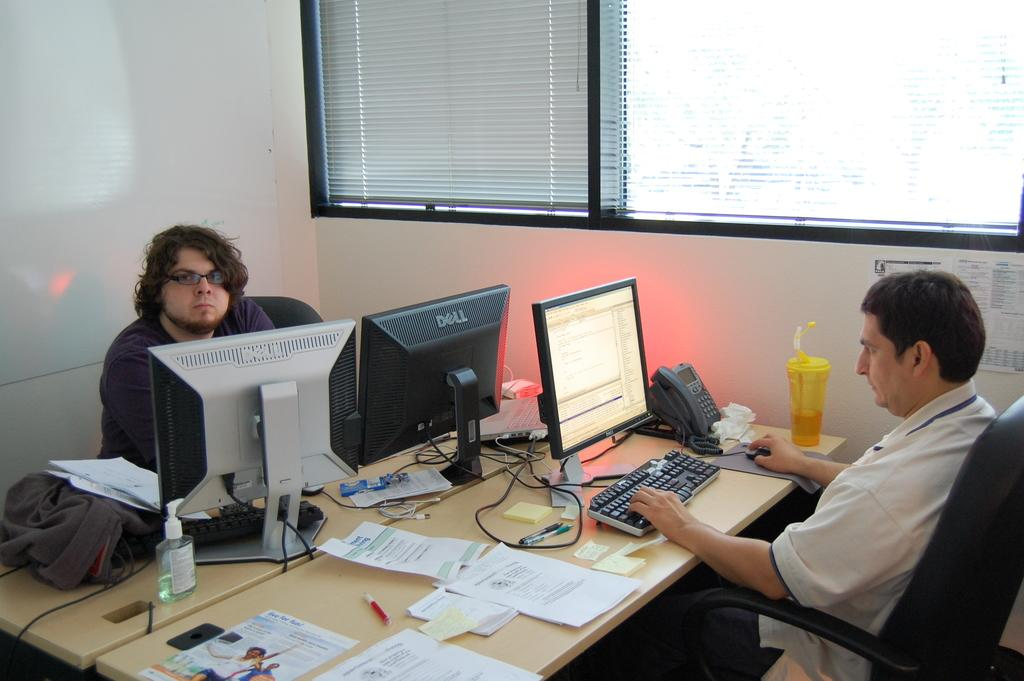<image>
Offer a succinct explanation of the picture presented. A man works at a desk in front of two Dell monitors. 